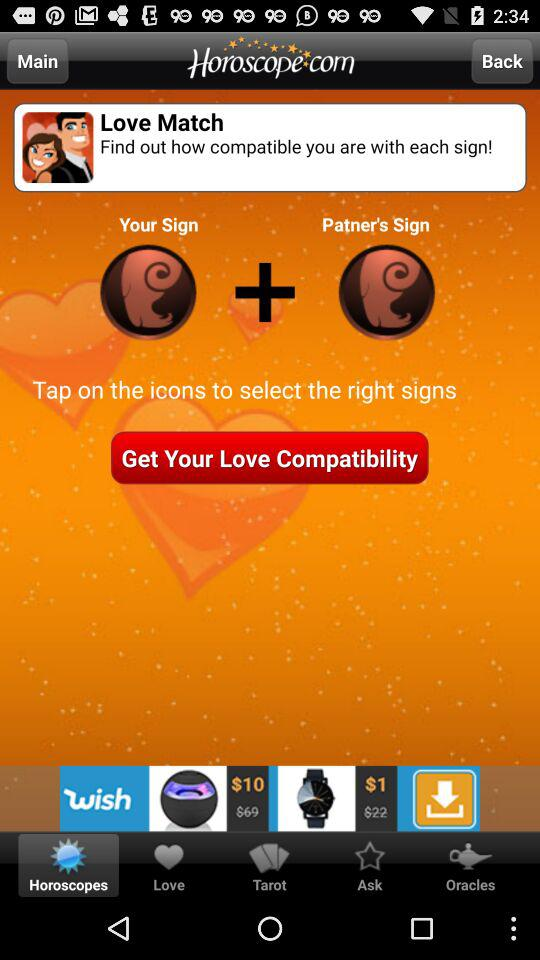What is the application name? The application name is "Horoscope.com". 